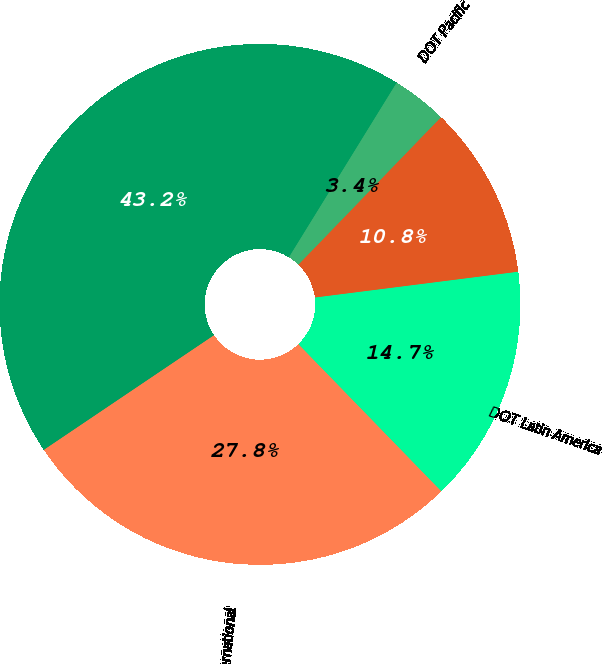<chart> <loc_0><loc_0><loc_500><loc_500><pie_chart><fcel>DOT Domestic<fcel>International<fcel>DOT Latin America<fcel>DOT Atlantic<fcel>DOT Pacific<nl><fcel>43.23%<fcel>27.83%<fcel>14.74%<fcel>10.76%<fcel>3.43%<nl></chart> 